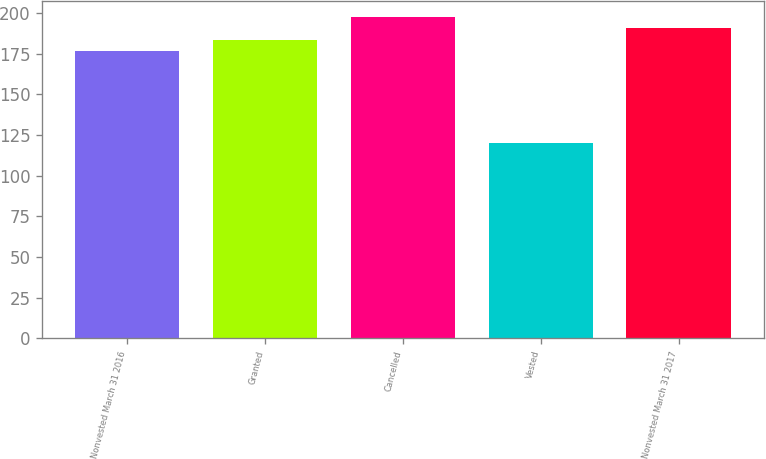Convert chart to OTSL. <chart><loc_0><loc_0><loc_500><loc_500><bar_chart><fcel>Nonvested March 31 2016<fcel>Granted<fcel>Cancelled<fcel>Vested<fcel>Nonvested March 31 2017<nl><fcel>176.59<fcel>183.63<fcel>197.71<fcel>119.96<fcel>190.67<nl></chart> 